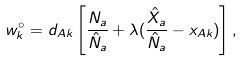Convert formula to latex. <formula><loc_0><loc_0><loc_500><loc_500>w _ { k } ^ { \circ } = d _ { A k } \left [ \frac { N _ { a } } { \hat { N } _ { a } } + \lambda ( \frac { \hat { X } _ { a } } { \hat { N } _ { a } } - x _ { A k } ) \right ] ,</formula> 